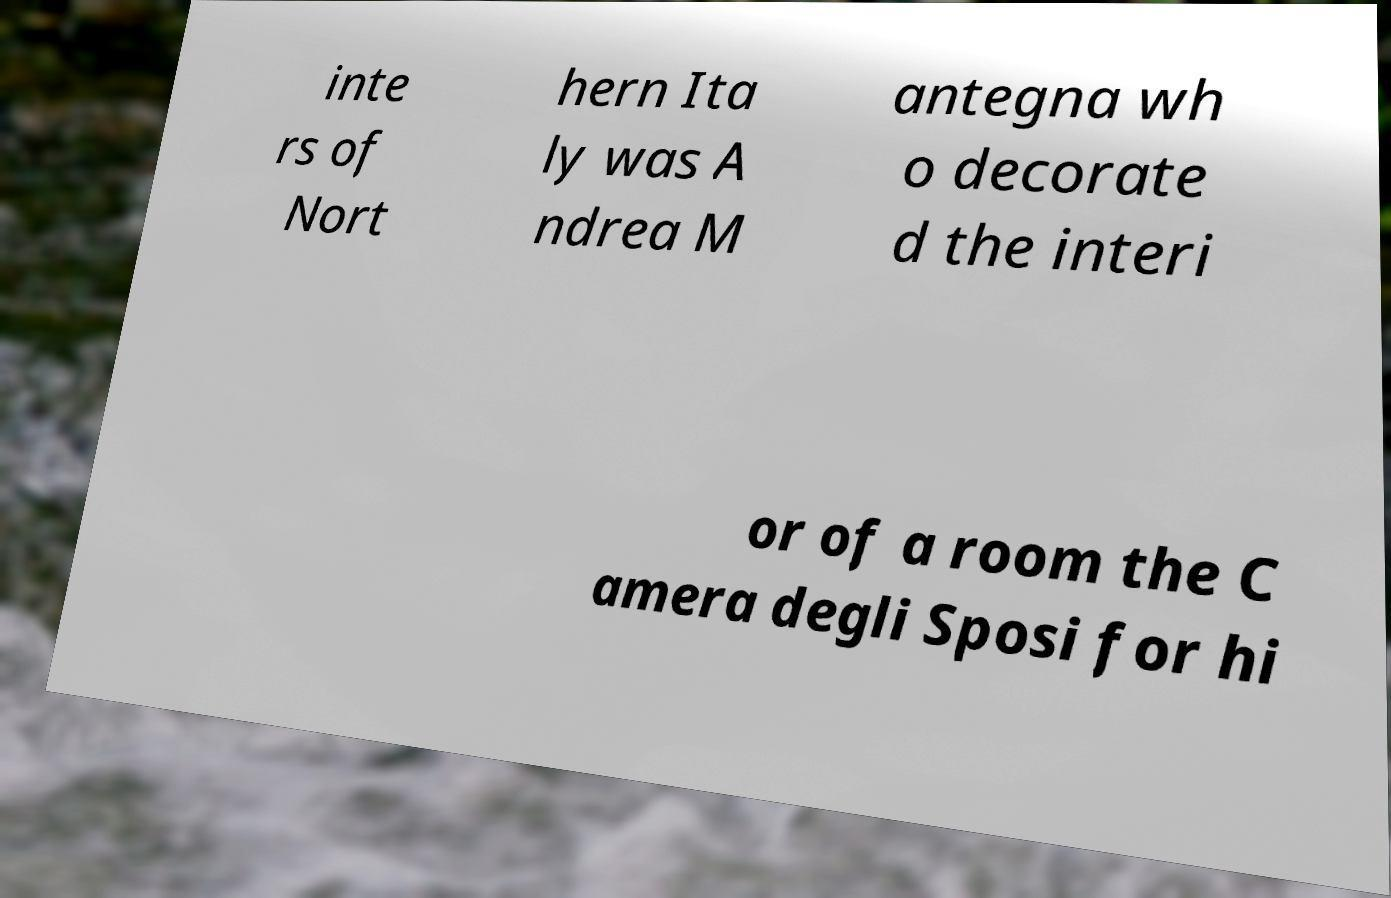Could you extract and type out the text from this image? inte rs of Nort hern Ita ly was A ndrea M antegna wh o decorate d the interi or of a room the C amera degli Sposi for hi 